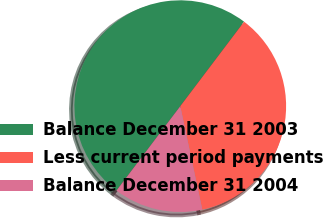Convert chart. <chart><loc_0><loc_0><loc_500><loc_500><pie_chart><fcel>Balance December 31 2003<fcel>Less current period payments<fcel>Balance December 31 2004<nl><fcel>50.0%<fcel>36.36%<fcel>13.64%<nl></chart> 